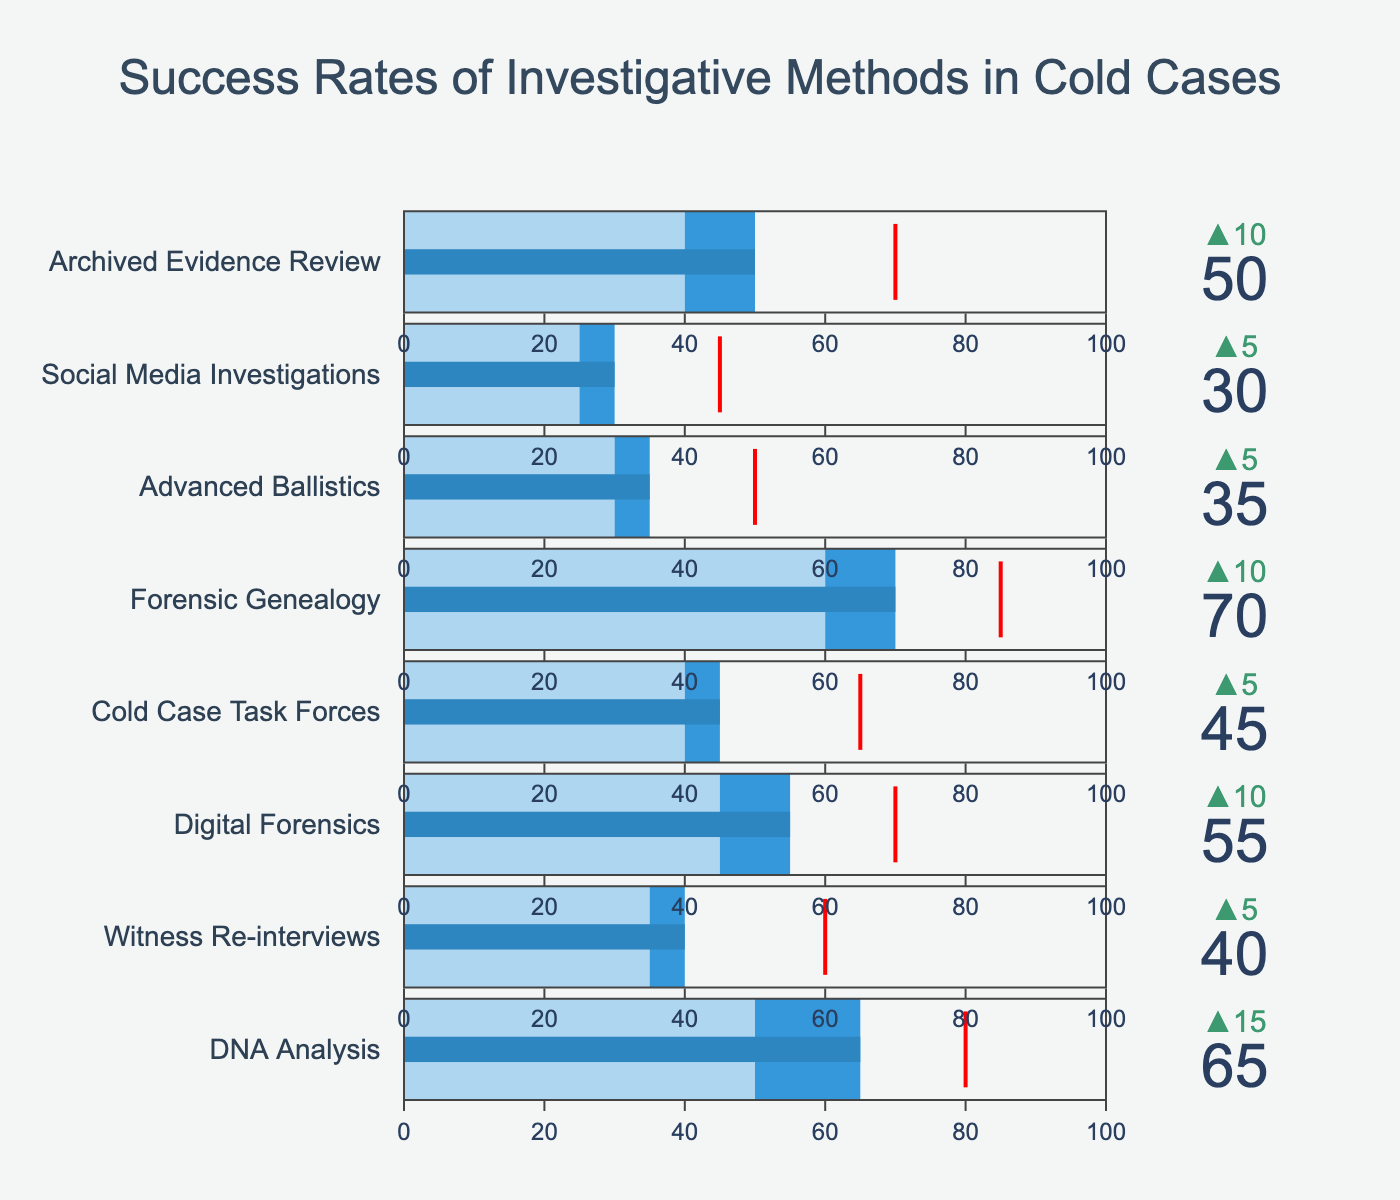What is the title of the figure? The title is usually displayed at the top and conveys the main subject of the chart.
Answer: Success Rates of Investigative Methods in Cold Cases How many investigative methods are shown in the figure? The number of methods corresponds to the number of bullet bars, one for each method. Count these bars.
Answer: 8 Which investigative method has the highest success rate? Look for the bullet bar with the highest 'Actual' value.
Answer: Forensic Genealogy What is the success rate for Social Media Investigations? Find the bullet bar for Social Media Investigations and read the 'Actual' value.
Answer: 30 Is the success rate for Digital Forensics above or below its target? Compare the 'Actual' value with the 'Target' value for Digital Forensics.
Answer: Below What is the difference between the success rate of DNA Analysis and its target? Subtract the 'Target' value from the 'Actual' value for DNA Analysis.
Answer: -15 Which two investigative methods have the closest success rates? Compare the 'Actual' values and identify the two methods with the smallest difference between them.
Answer: Cold Case Task Forces and Archived Evidence Review How does the success rate of Advanced Ballistics compare to its comparative value? Compare the 'Actual' value with the 'Comparative' value for Advanced Ballistics.
Answer: Higher Which method has the largest gap between its actual and comparative success rates? Calculate the difference between the 'Actual' and 'Comparative' values for each method and find the largest gap.
Answer: Forensic Genealogy Which method is closest to meeting its target? Calculate the difference between the 'Actual' and 'Target' values for each method and find the smallest positive difference.
Answer: Archived Evidence Review 